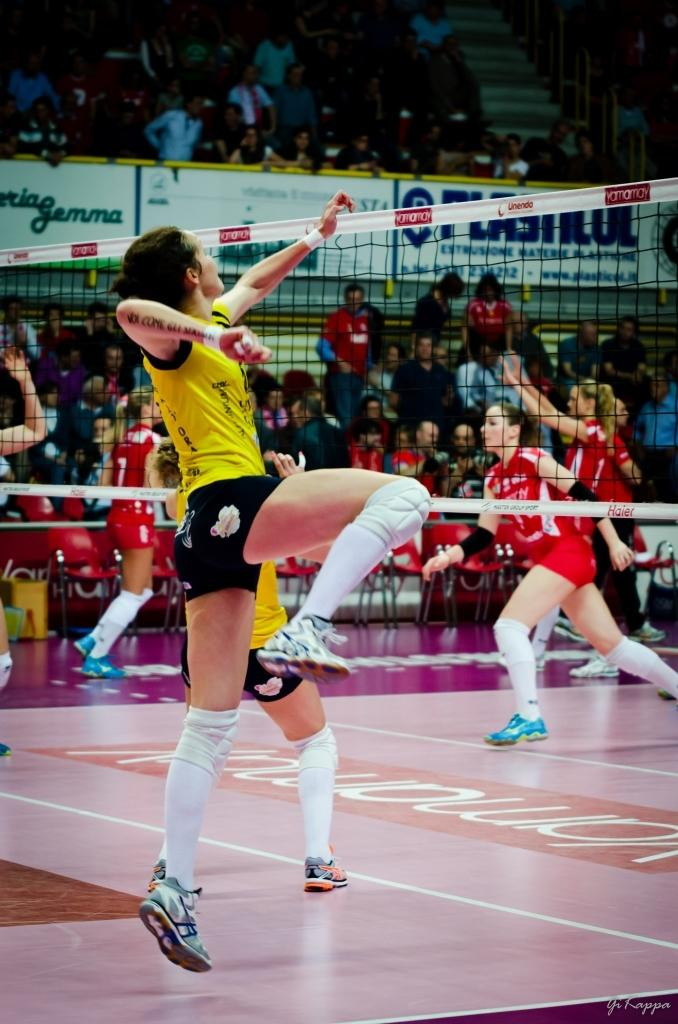Who is the main subject in the image? There is a person in the image. What is the person doing in the image? The person is jumping. What is in front of the person in the image? There is a net in front of the person. What can be seen in the background of the image? There are people standing and sitting in the stadium behind the net. What type of spring is visible in the image? There is no spring present in the image. How many cattle can be seen in the image? There are no cattle present in the image. 